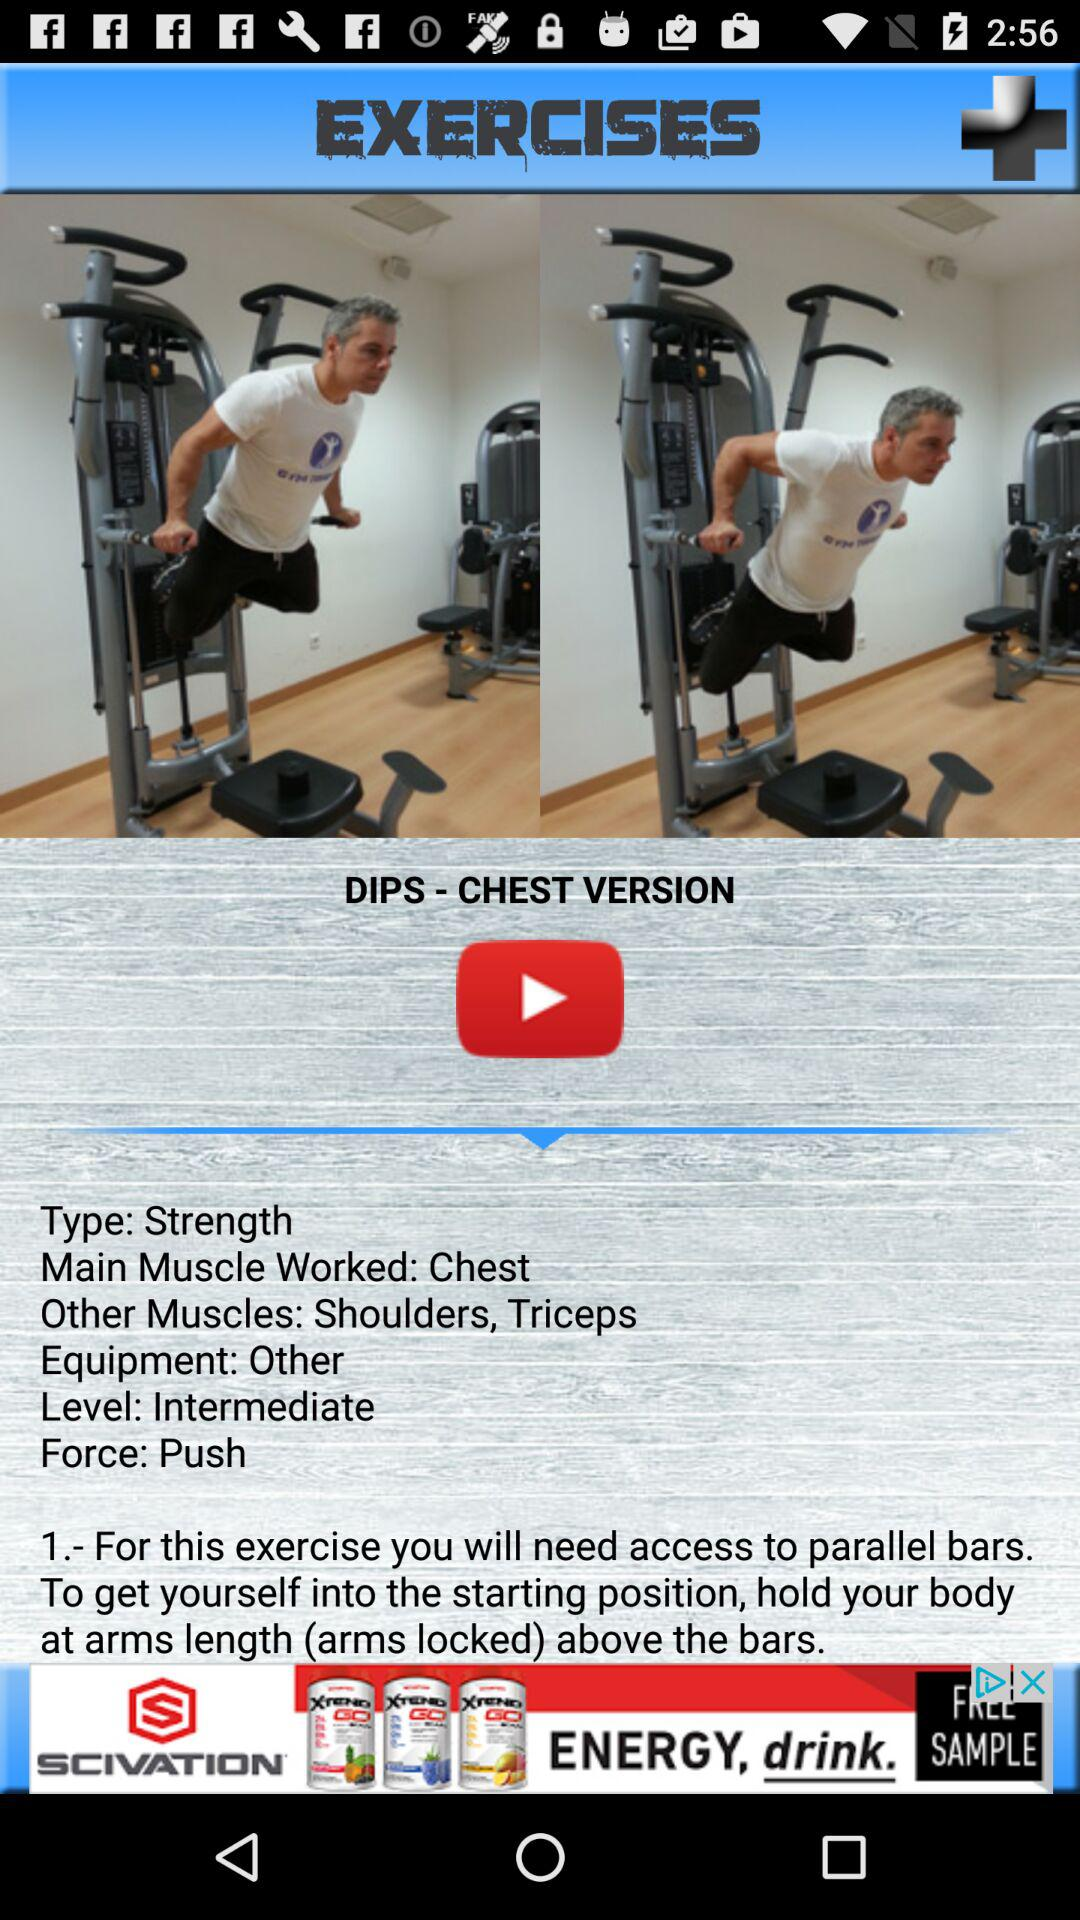How many steps are there in the instructions?
Answer the question using a single word or phrase. 1 